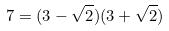Convert formula to latex. <formula><loc_0><loc_0><loc_500><loc_500>7 = ( 3 - \sqrt { 2 } ) ( 3 + \sqrt { 2 } )</formula> 